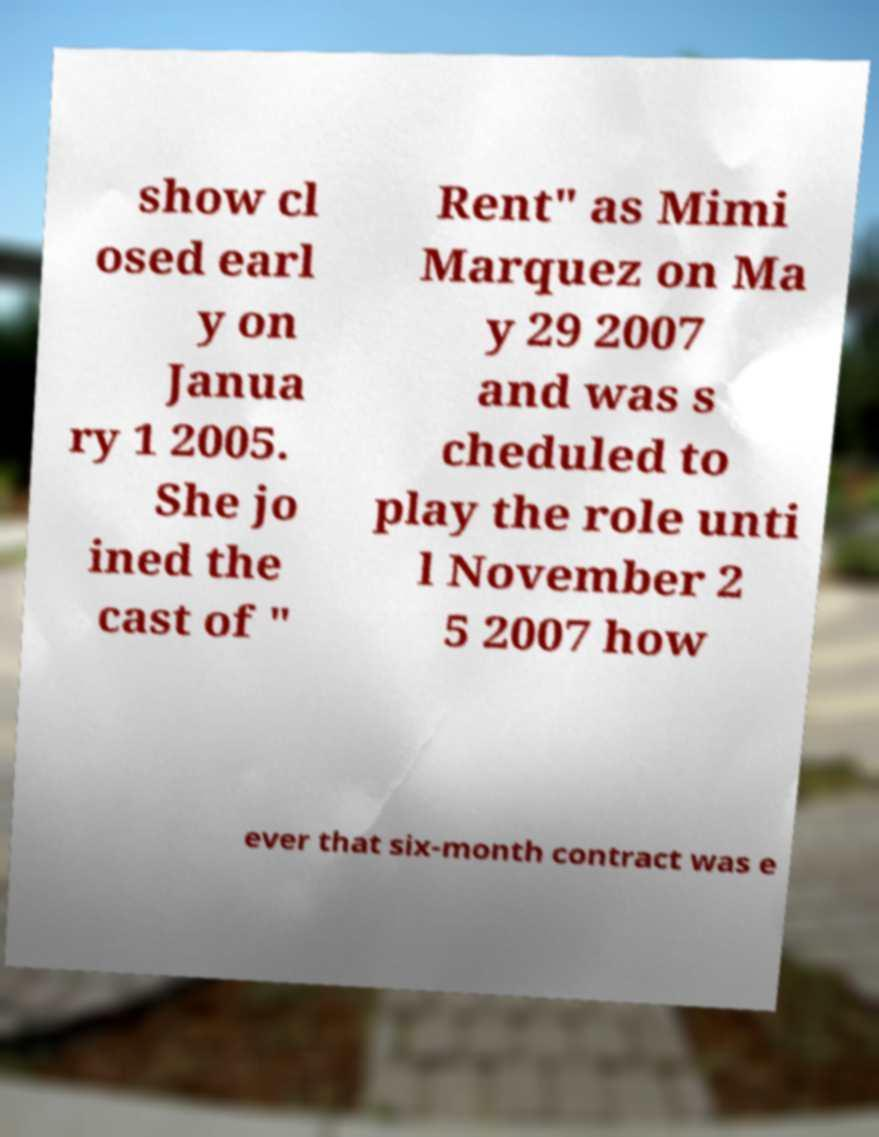Please identify and transcribe the text found in this image. show cl osed earl y on Janua ry 1 2005. She jo ined the cast of " Rent" as Mimi Marquez on Ma y 29 2007 and was s cheduled to play the role unti l November 2 5 2007 how ever that six-month contract was e 